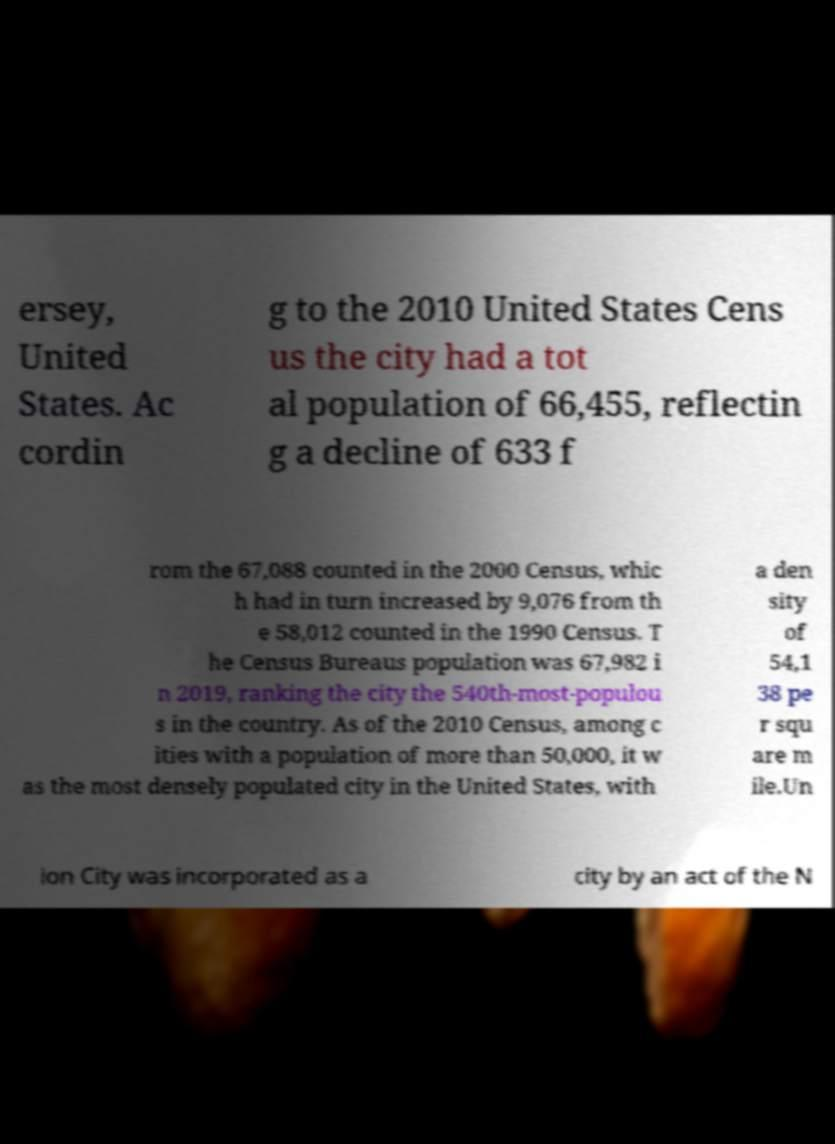Can you accurately transcribe the text from the provided image for me? ersey, United States. Ac cordin g to the 2010 United States Cens us the city had a tot al population of 66,455, reflectin g a decline of 633 f rom the 67,088 counted in the 2000 Census, whic h had in turn increased by 9,076 from th e 58,012 counted in the 1990 Census. T he Census Bureaus population was 67,982 i n 2019, ranking the city the 540th-most-populou s in the country. As of the 2010 Census, among c ities with a population of more than 50,000, it w as the most densely populated city in the United States, with a den sity of 54,1 38 pe r squ are m ile.Un ion City was incorporated as a city by an act of the N 